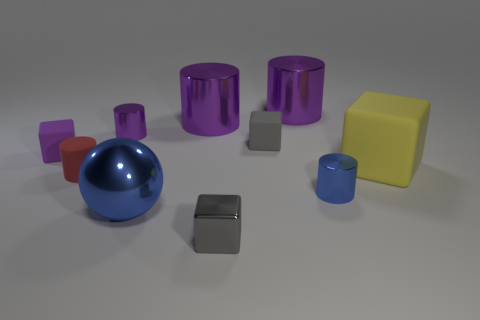There is a tiny block that is in front of the large blue shiny sphere; is it the same color as the tiny rubber object that is right of the small gray shiny object?
Provide a short and direct response. Yes. What material is the purple block?
Provide a short and direct response. Rubber. Is there any other thing that is the same color as the small matte cylinder?
Your answer should be very brief. No. Are the tiny red cylinder and the large cube made of the same material?
Give a very brief answer. Yes. How many gray blocks are in front of the tiny gray cube that is behind the blue thing that is right of the gray rubber thing?
Ensure brevity in your answer.  1. How many green matte balls are there?
Offer a very short reply. 0. Are there fewer shiny balls that are behind the tiny blue shiny object than big shiny things that are in front of the gray rubber thing?
Your answer should be very brief. Yes. Are there fewer tiny gray matte objects in front of the yellow cube than brown balls?
Offer a terse response. No. What is the tiny purple object that is to the right of the purple object that is left of the small metallic cylinder that is behind the tiny red cylinder made of?
Provide a short and direct response. Metal. How many objects are metal things in front of the small blue object or tiny gray cubes that are behind the yellow block?
Offer a terse response. 3. 